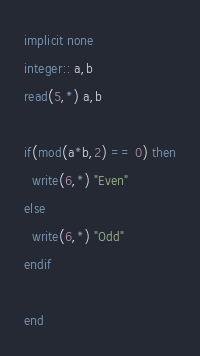Convert code to text. <code><loc_0><loc_0><loc_500><loc_500><_FORTRAN_>implicit none
integer:: a,b
read(5,*) a,b

if(mod(a*b,2) == 0) then
  write(6,*) "Even"
else
  write(6,*) "Odd"
endif

end
</code> 